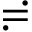<formula> <loc_0><loc_0><loc_500><loc_500>\risingdotseq</formula> 